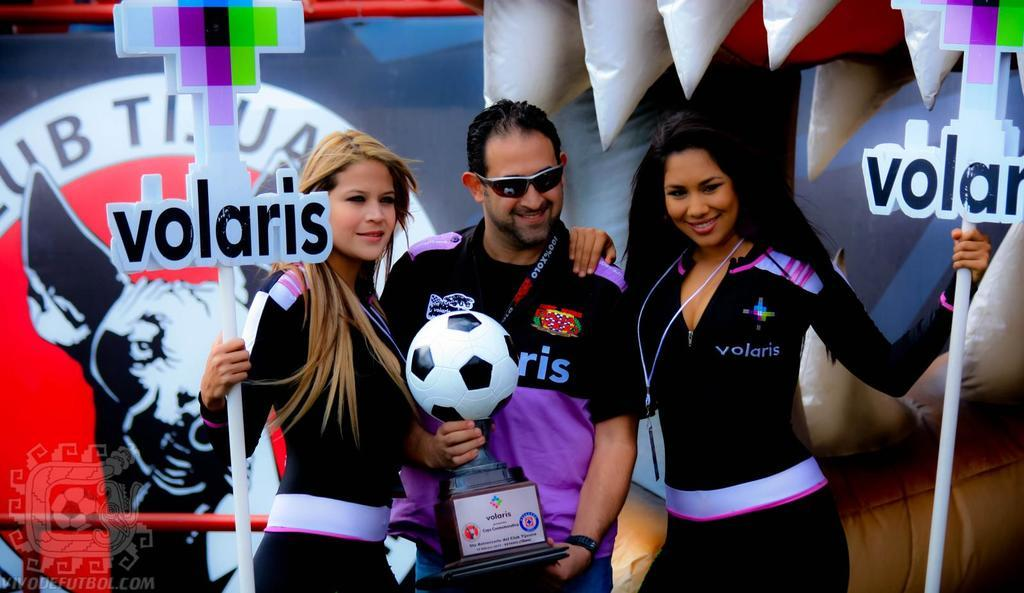<image>
Describe the image concisely. Two girls hold signs for Volaris while a man holds a soccer trophy. 